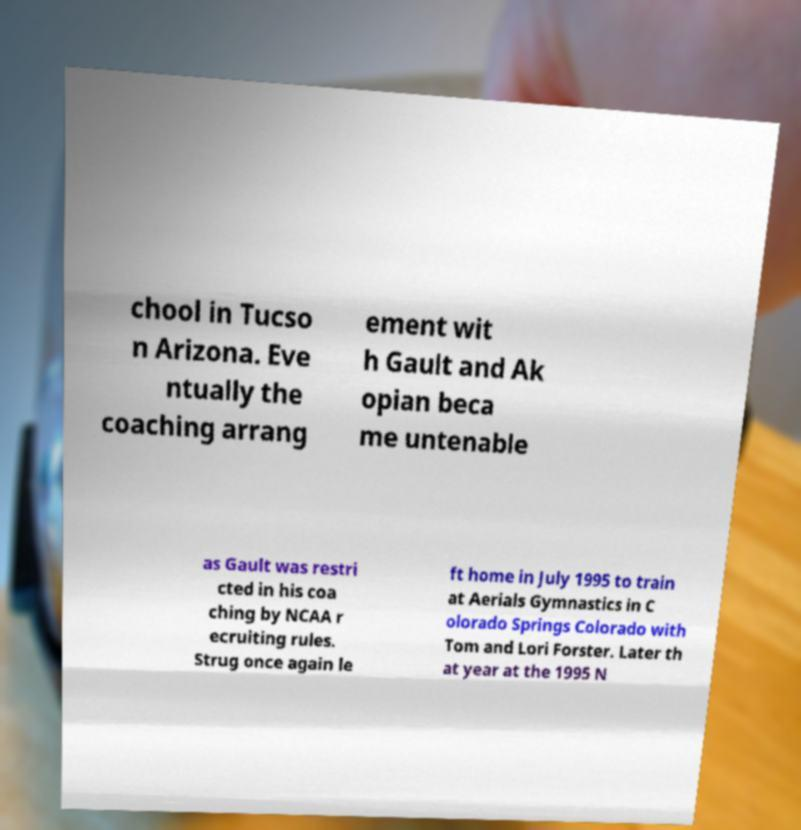What messages or text are displayed in this image? I need them in a readable, typed format. chool in Tucso n Arizona. Eve ntually the coaching arrang ement wit h Gault and Ak opian beca me untenable as Gault was restri cted in his coa ching by NCAA r ecruiting rules. Strug once again le ft home in July 1995 to train at Aerials Gymnastics in C olorado Springs Colorado with Tom and Lori Forster. Later th at year at the 1995 N 